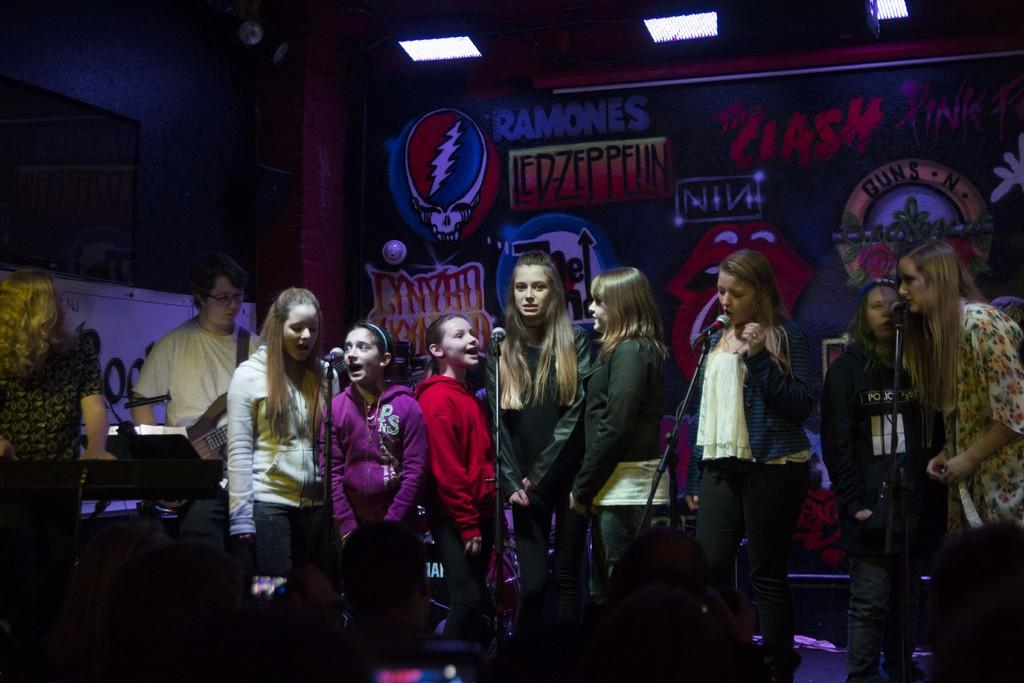How many people are in the image? There is a group of people in the image, but the exact number is not specified. What objects are present that are used for amplifying sound? There are microphones (mics) in the image. What type of lighting is visible in the image? There are lights in the image. What type of decorative or informative items are present in the image? There are banners in the image. Can you describe any other objects that are not specified in the facts? There are unspecified objects in the image. What type of wood can be seen in the image? There is no wood present in the image. What sign is displayed on the wall in the image? There is no sign displayed on the wall in the image. 